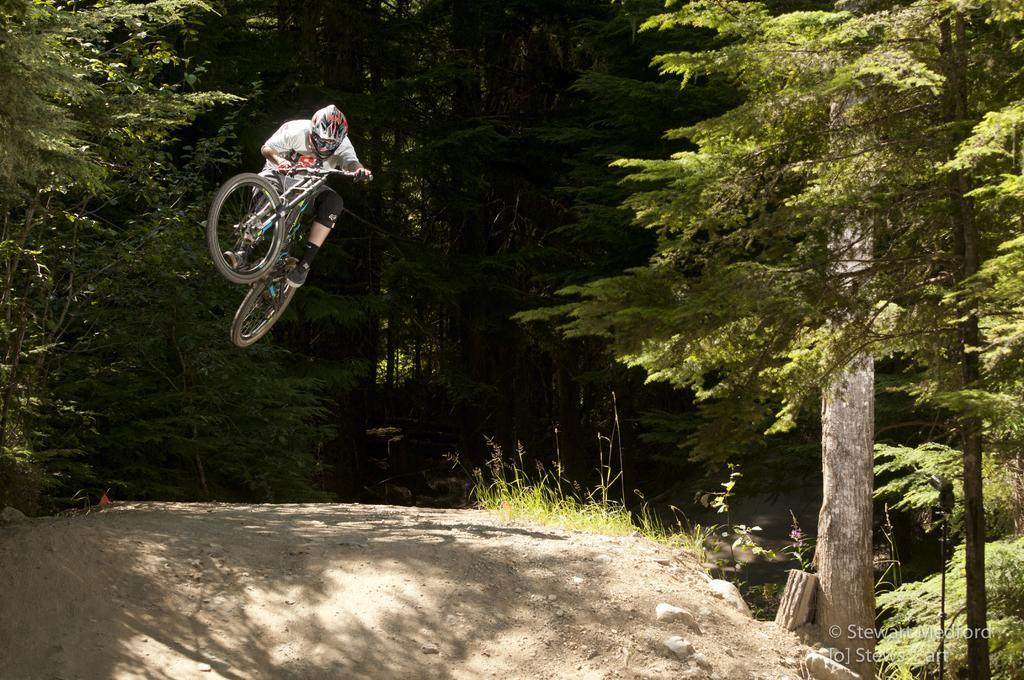Could you give a brief overview of what you see in this image? In this image we can see a person cycling and behind him there are trees and plants, at the bottom right corner of the image there is some text. 